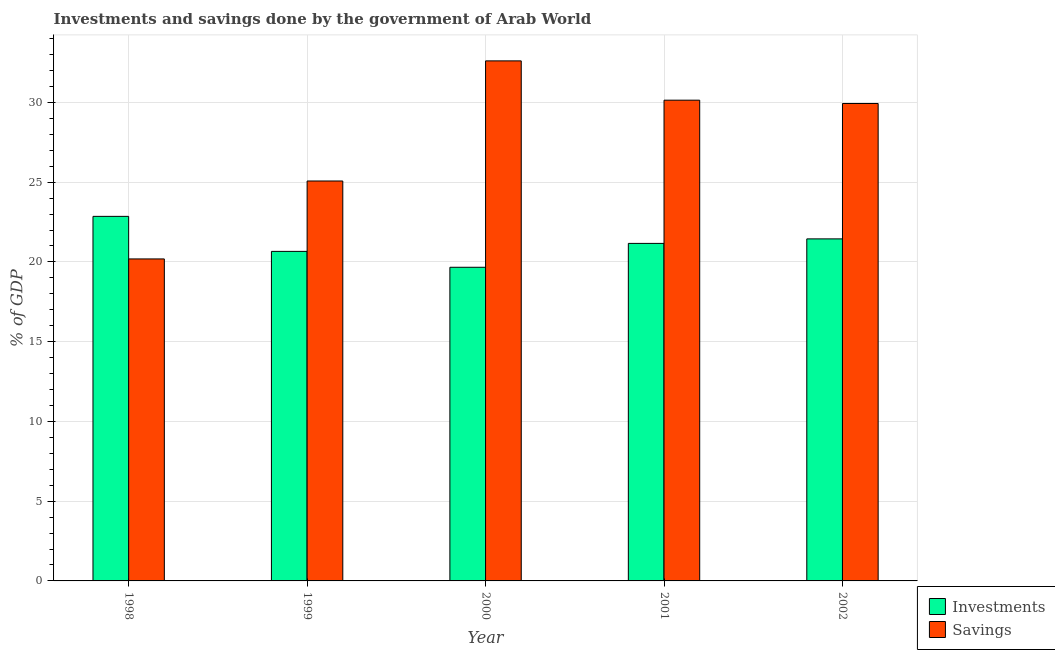How many different coloured bars are there?
Provide a succinct answer. 2. Are the number of bars per tick equal to the number of legend labels?
Provide a short and direct response. Yes. Are the number of bars on each tick of the X-axis equal?
Provide a short and direct response. Yes. How many bars are there on the 1st tick from the left?
Make the answer very short. 2. How many bars are there on the 4th tick from the right?
Provide a short and direct response. 2. What is the label of the 5th group of bars from the left?
Make the answer very short. 2002. In how many cases, is the number of bars for a given year not equal to the number of legend labels?
Provide a succinct answer. 0. What is the investments of government in 1999?
Make the answer very short. 20.66. Across all years, what is the maximum savings of government?
Provide a short and direct response. 32.61. Across all years, what is the minimum investments of government?
Your answer should be very brief. 19.67. In which year was the savings of government maximum?
Provide a short and direct response. 2000. What is the total savings of government in the graph?
Your response must be concise. 137.95. What is the difference between the investments of government in 2001 and that in 2002?
Offer a terse response. -0.28. What is the difference between the investments of government in 1998 and the savings of government in 1999?
Offer a terse response. 2.19. What is the average investments of government per year?
Ensure brevity in your answer.  21.16. What is the ratio of the savings of government in 1998 to that in 2001?
Offer a terse response. 0.67. Is the difference between the investments of government in 1999 and 2000 greater than the difference between the savings of government in 1999 and 2000?
Offer a terse response. No. What is the difference between the highest and the second highest savings of government?
Offer a very short reply. 2.46. What is the difference between the highest and the lowest investments of government?
Provide a short and direct response. 3.19. What does the 1st bar from the left in 2000 represents?
Provide a short and direct response. Investments. What does the 1st bar from the right in 2000 represents?
Make the answer very short. Savings. Are the values on the major ticks of Y-axis written in scientific E-notation?
Provide a short and direct response. No. Does the graph contain any zero values?
Give a very brief answer. No. Does the graph contain grids?
Offer a very short reply. Yes. What is the title of the graph?
Offer a terse response. Investments and savings done by the government of Arab World. Does "constant 2005 US$" appear as one of the legend labels in the graph?
Make the answer very short. No. What is the label or title of the Y-axis?
Your answer should be very brief. % of GDP. What is the % of GDP in Investments in 1998?
Provide a short and direct response. 22.86. What is the % of GDP of Savings in 1998?
Your answer should be compact. 20.19. What is the % of GDP in Investments in 1999?
Your answer should be compact. 20.66. What is the % of GDP of Savings in 1999?
Keep it short and to the point. 25.08. What is the % of GDP in Investments in 2000?
Give a very brief answer. 19.67. What is the % of GDP of Savings in 2000?
Your answer should be very brief. 32.61. What is the % of GDP of Investments in 2001?
Keep it short and to the point. 21.16. What is the % of GDP in Savings in 2001?
Provide a succinct answer. 30.14. What is the % of GDP of Investments in 2002?
Offer a terse response. 21.45. What is the % of GDP of Savings in 2002?
Your answer should be very brief. 29.93. Across all years, what is the maximum % of GDP of Investments?
Ensure brevity in your answer.  22.86. Across all years, what is the maximum % of GDP of Savings?
Your answer should be compact. 32.61. Across all years, what is the minimum % of GDP of Investments?
Give a very brief answer. 19.67. Across all years, what is the minimum % of GDP of Savings?
Keep it short and to the point. 20.19. What is the total % of GDP of Investments in the graph?
Provide a short and direct response. 105.79. What is the total % of GDP in Savings in the graph?
Offer a terse response. 137.95. What is the difference between the % of GDP in Investments in 1998 and that in 1999?
Offer a very short reply. 2.19. What is the difference between the % of GDP in Savings in 1998 and that in 1999?
Ensure brevity in your answer.  -4.89. What is the difference between the % of GDP in Investments in 1998 and that in 2000?
Offer a terse response. 3.19. What is the difference between the % of GDP in Savings in 1998 and that in 2000?
Your answer should be very brief. -12.42. What is the difference between the % of GDP in Investments in 1998 and that in 2001?
Offer a terse response. 1.69. What is the difference between the % of GDP of Savings in 1998 and that in 2001?
Keep it short and to the point. -9.95. What is the difference between the % of GDP of Investments in 1998 and that in 2002?
Offer a terse response. 1.41. What is the difference between the % of GDP in Savings in 1998 and that in 2002?
Your response must be concise. -9.75. What is the difference between the % of GDP in Investments in 1999 and that in 2000?
Keep it short and to the point. 1. What is the difference between the % of GDP of Savings in 1999 and that in 2000?
Your answer should be compact. -7.53. What is the difference between the % of GDP of Investments in 1999 and that in 2001?
Your answer should be very brief. -0.5. What is the difference between the % of GDP in Savings in 1999 and that in 2001?
Your response must be concise. -5.07. What is the difference between the % of GDP in Investments in 1999 and that in 2002?
Your answer should be compact. -0.78. What is the difference between the % of GDP of Savings in 1999 and that in 2002?
Ensure brevity in your answer.  -4.86. What is the difference between the % of GDP of Investments in 2000 and that in 2001?
Keep it short and to the point. -1.5. What is the difference between the % of GDP of Savings in 2000 and that in 2001?
Ensure brevity in your answer.  2.46. What is the difference between the % of GDP in Investments in 2000 and that in 2002?
Your answer should be compact. -1.78. What is the difference between the % of GDP in Savings in 2000 and that in 2002?
Give a very brief answer. 2.67. What is the difference between the % of GDP in Investments in 2001 and that in 2002?
Your answer should be compact. -0.28. What is the difference between the % of GDP in Savings in 2001 and that in 2002?
Provide a short and direct response. 0.21. What is the difference between the % of GDP in Investments in 1998 and the % of GDP in Savings in 1999?
Give a very brief answer. -2.22. What is the difference between the % of GDP in Investments in 1998 and the % of GDP in Savings in 2000?
Your answer should be very brief. -9.75. What is the difference between the % of GDP in Investments in 1998 and the % of GDP in Savings in 2001?
Your response must be concise. -7.29. What is the difference between the % of GDP in Investments in 1998 and the % of GDP in Savings in 2002?
Give a very brief answer. -7.08. What is the difference between the % of GDP in Investments in 1999 and the % of GDP in Savings in 2000?
Make the answer very short. -11.94. What is the difference between the % of GDP in Investments in 1999 and the % of GDP in Savings in 2001?
Make the answer very short. -9.48. What is the difference between the % of GDP in Investments in 1999 and the % of GDP in Savings in 2002?
Offer a terse response. -9.27. What is the difference between the % of GDP of Investments in 2000 and the % of GDP of Savings in 2001?
Keep it short and to the point. -10.48. What is the difference between the % of GDP in Investments in 2000 and the % of GDP in Savings in 2002?
Ensure brevity in your answer.  -10.27. What is the difference between the % of GDP in Investments in 2001 and the % of GDP in Savings in 2002?
Make the answer very short. -8.77. What is the average % of GDP in Investments per year?
Offer a terse response. 21.16. What is the average % of GDP of Savings per year?
Keep it short and to the point. 27.59. In the year 1998, what is the difference between the % of GDP in Investments and % of GDP in Savings?
Your answer should be very brief. 2.67. In the year 1999, what is the difference between the % of GDP of Investments and % of GDP of Savings?
Your answer should be very brief. -4.41. In the year 2000, what is the difference between the % of GDP in Investments and % of GDP in Savings?
Provide a short and direct response. -12.94. In the year 2001, what is the difference between the % of GDP of Investments and % of GDP of Savings?
Give a very brief answer. -8.98. In the year 2002, what is the difference between the % of GDP of Investments and % of GDP of Savings?
Your answer should be compact. -8.49. What is the ratio of the % of GDP of Investments in 1998 to that in 1999?
Your response must be concise. 1.11. What is the ratio of the % of GDP in Savings in 1998 to that in 1999?
Give a very brief answer. 0.81. What is the ratio of the % of GDP of Investments in 1998 to that in 2000?
Your answer should be very brief. 1.16. What is the ratio of the % of GDP of Savings in 1998 to that in 2000?
Your answer should be very brief. 0.62. What is the ratio of the % of GDP of Investments in 1998 to that in 2001?
Give a very brief answer. 1.08. What is the ratio of the % of GDP of Savings in 1998 to that in 2001?
Provide a short and direct response. 0.67. What is the ratio of the % of GDP in Investments in 1998 to that in 2002?
Your response must be concise. 1.07. What is the ratio of the % of GDP in Savings in 1998 to that in 2002?
Provide a short and direct response. 0.67. What is the ratio of the % of GDP of Investments in 1999 to that in 2000?
Offer a very short reply. 1.05. What is the ratio of the % of GDP of Savings in 1999 to that in 2000?
Ensure brevity in your answer.  0.77. What is the ratio of the % of GDP in Investments in 1999 to that in 2001?
Keep it short and to the point. 0.98. What is the ratio of the % of GDP in Savings in 1999 to that in 2001?
Keep it short and to the point. 0.83. What is the ratio of the % of GDP of Investments in 1999 to that in 2002?
Ensure brevity in your answer.  0.96. What is the ratio of the % of GDP in Savings in 1999 to that in 2002?
Give a very brief answer. 0.84. What is the ratio of the % of GDP of Investments in 2000 to that in 2001?
Give a very brief answer. 0.93. What is the ratio of the % of GDP of Savings in 2000 to that in 2001?
Keep it short and to the point. 1.08. What is the ratio of the % of GDP in Investments in 2000 to that in 2002?
Your answer should be compact. 0.92. What is the ratio of the % of GDP in Savings in 2000 to that in 2002?
Your response must be concise. 1.09. What is the ratio of the % of GDP of Investments in 2001 to that in 2002?
Offer a very short reply. 0.99. What is the ratio of the % of GDP in Savings in 2001 to that in 2002?
Give a very brief answer. 1.01. What is the difference between the highest and the second highest % of GDP of Investments?
Ensure brevity in your answer.  1.41. What is the difference between the highest and the second highest % of GDP of Savings?
Offer a terse response. 2.46. What is the difference between the highest and the lowest % of GDP of Investments?
Your answer should be compact. 3.19. What is the difference between the highest and the lowest % of GDP of Savings?
Offer a terse response. 12.42. 